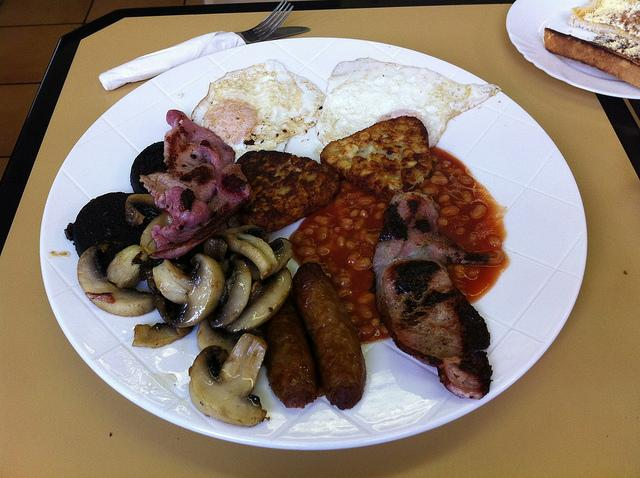How many eggs are served beside the hash browns in this breakfast plate?

Choices:
A) three
B) four
C) five
D) two two 